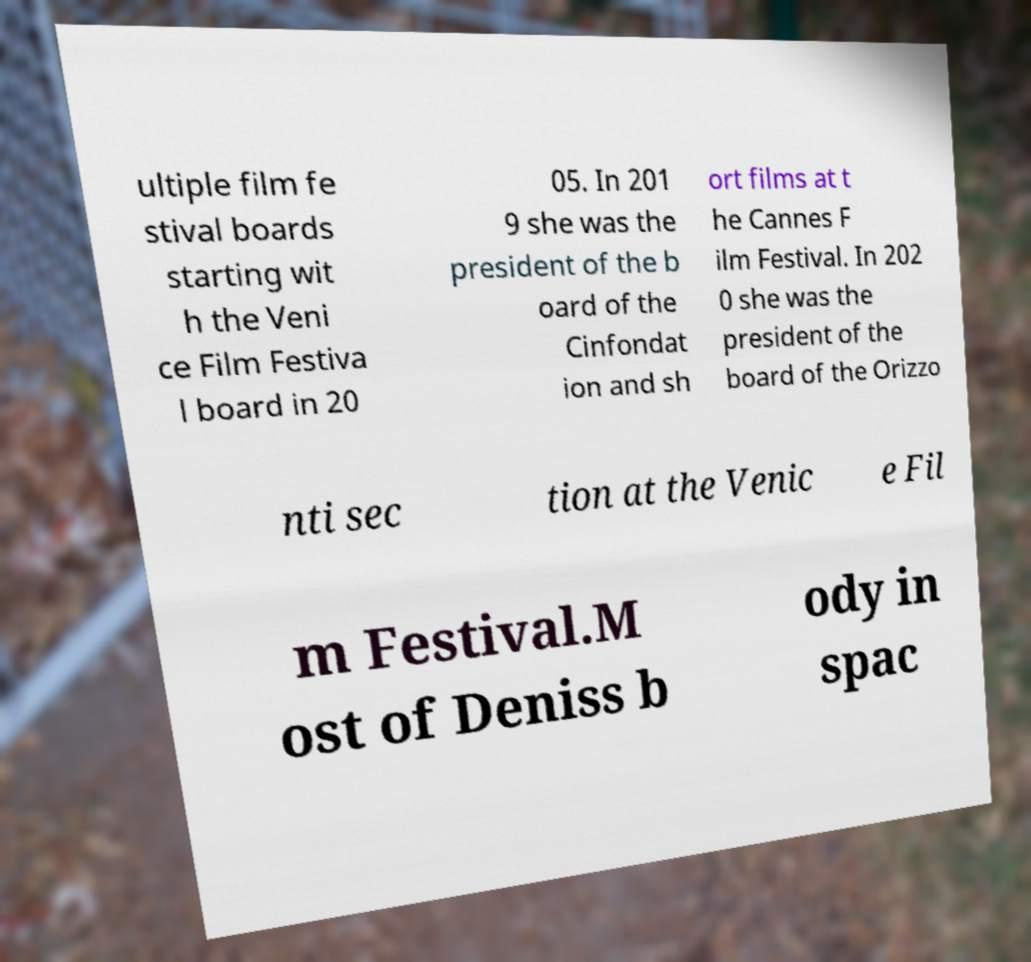I need the written content from this picture converted into text. Can you do that? ultiple film fe stival boards starting wit h the Veni ce Film Festiva l board in 20 05. In 201 9 she was the president of the b oard of the Cinfondat ion and sh ort films at t he Cannes F ilm Festival. In 202 0 she was the president of the board of the Orizzo nti sec tion at the Venic e Fil m Festival.M ost of Deniss b ody in spac 